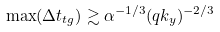Convert formula to latex. <formula><loc_0><loc_0><loc_500><loc_500>\max ( \Delta t _ { t g } ) \gtrsim \alpha ^ { - 1 / 3 } ( q k _ { y } ) ^ { - 2 / 3 }</formula> 